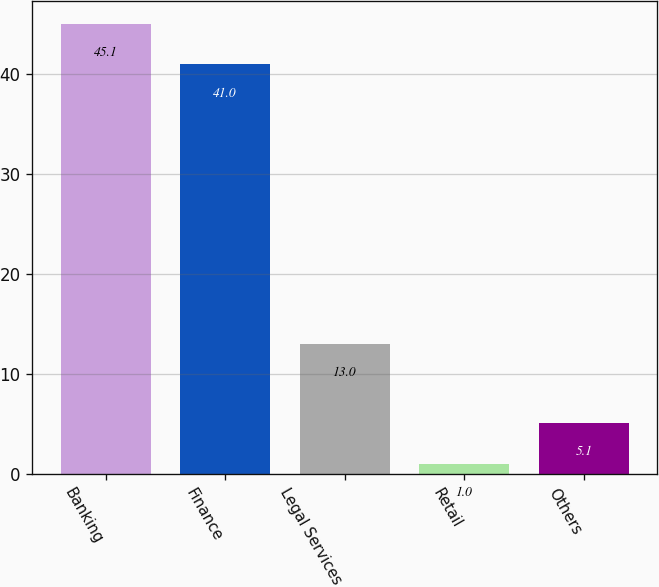<chart> <loc_0><loc_0><loc_500><loc_500><bar_chart><fcel>Banking<fcel>Finance<fcel>Legal Services<fcel>Retail<fcel>Others<nl><fcel>45.1<fcel>41<fcel>13<fcel>1<fcel>5.1<nl></chart> 